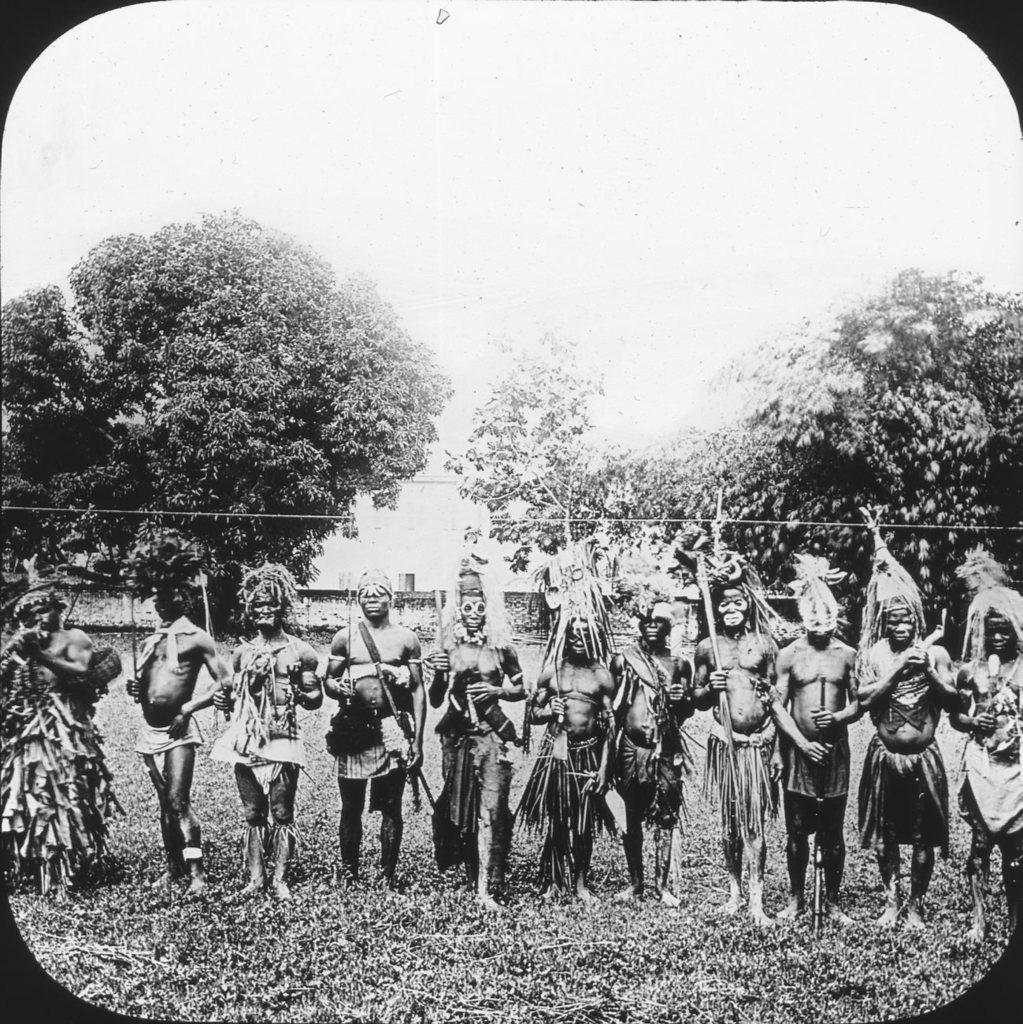What is the color scheme of the image? The image is black and white. Who or what can be seen in the image? There are people in the image. What are the people wearing? The people are wearing tribal attire. Where are the people standing? The people are standing on a grassland. What can be seen in the background of the image? There are trees in the background of the image. What type of butter is being used to create the intricate details on the people's clothing in the image? There are no details or butter present in the image; it is a black and white photograph of people wearing tribal attire standing on a grassland with trees in the background. 